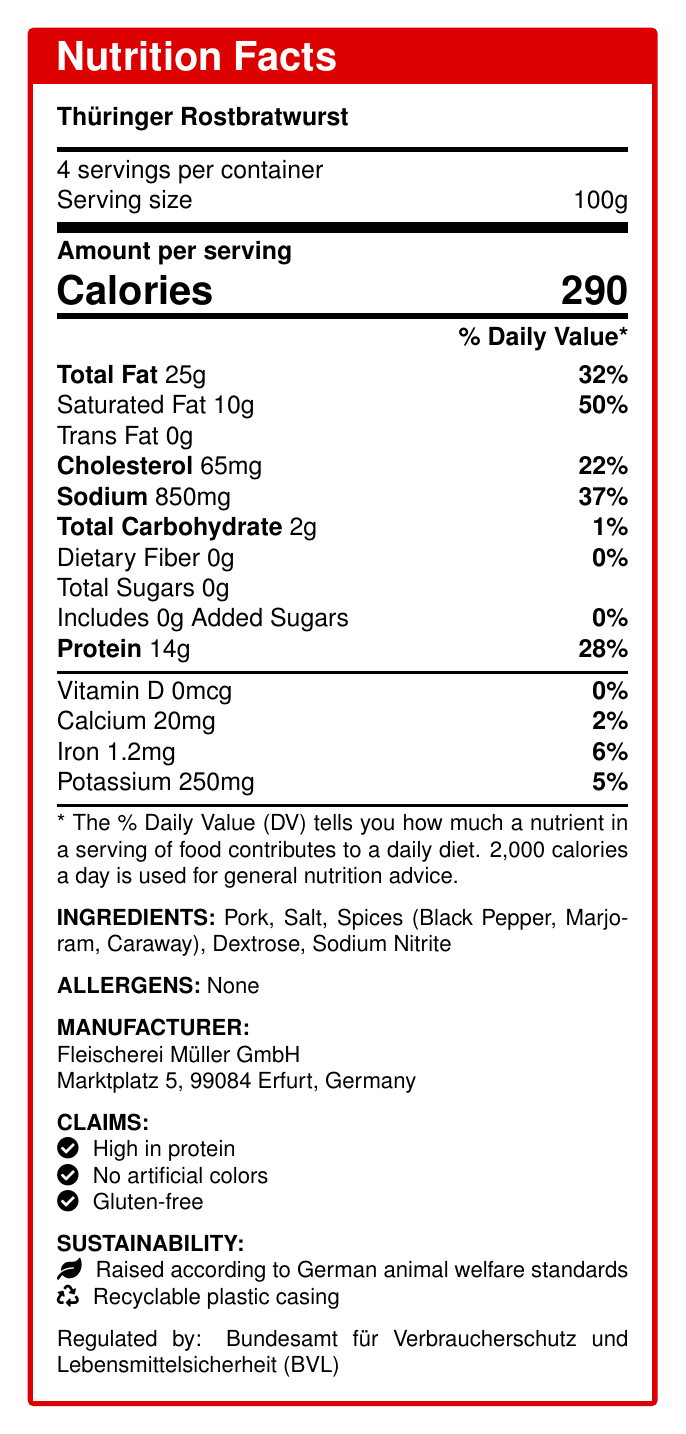what is the serving size for Thüringer Rostbratwurst? The document states that the serving size for Thüringer Rostbratwurst is 100g.
Answer: 100g how many servings are there per container? The document indicates there are 4 servings per container.
Answer: 4 how many calories are there per serving? The document lists the amount of calories per serving as 290.
Answer: 290 how much protein is in one serving of Thüringer Rostbratwurst? The amount of protein per serving is specified as 14g in the document.
Answer: 14g what is the percent daily value of saturated fat per serving? The document shows that the percent daily value of saturated fat per serving is 50%.
Answer: 50% which body regulates the nutritional information of Thüringer Rostbratwurst? A. Bundesministerium für Ernährung und Landwirtschaft (BMEL) B. Bundesamt für Verbraucherschutz und Lebensmittelsicherheit (BVL) C. Deutsche Gesellschaft für Ernährung (DGE) D. Lebensmittelüberwachung und Tiergesundheit (LÜT) The document states that the information is regulated by the Bundesamt für Verbraucherschutz und Lebensmittelsicherheit (BVL).
Answer: B. Bundesamt für Verbraucherschutz und Lebensmittelsicherheit (BVL) which of the following is *not* listed as an ingredient in Thüringer Rostbratwurst? i. Salt ii. Marjoram iii. Garlic iv. Dextrose The document lists Pork, Salt, Spices (Black Pepper, Marjoram, Caraway), Dextrose, and Sodium Nitrite as ingredients but does not mention Garlic.
Answer: iii. Garlic is Thüringer Rostbratwurst high in protein? The document makes the claim that Thüringer Rostbratwurst is high in protein.
Answer: Yes provide a summary of the nutritional values and other key information about Thüringer Rostbratwurst. This summary includes the nutritional values, ingredients, allergen information, manufacturer details, nutritional claims, and sustainability info as provided in the document.
Answer: Thüringer Rostbratwurst has 290 calories per 100g serving, with 25g of total fat including 10g of saturated fat. It contains 14g of protein and 2g of total carbohydrates. It has 65mg of cholesterol, 850mg of sodium, and minimal amounts of vitamins and minerals like calcium, iron, and potassium. The ingredients include pork, salt, spices, dextrose, and sodium nitrite, and it contains no allergens. Manufactured by Fleischerei Müller GmbH, it is claimed to be high in protein, free from artificial colors, and gluten-free, with emphasis on sustainability and animal welfare. what is the amount of cholesterol in one serving? The document specifies that one serving contains 65mg of cholesterol.
Answer: 65mg how much sodium does a single serving of Thüringer Rostbratwurst contain? The amount of sodium per serving is listed as 850mg in the document.
Answer: 850mg what is the percent daily value of total fat in a serving? The document indicates that the percent daily value for total fat in one serving is 32%.
Answer: 32% does the document provide any information about the product's impact on specific illnesses? The document does not provide any specific information regarding the product's impact on particular illnesses.
Answer: Not enough information 